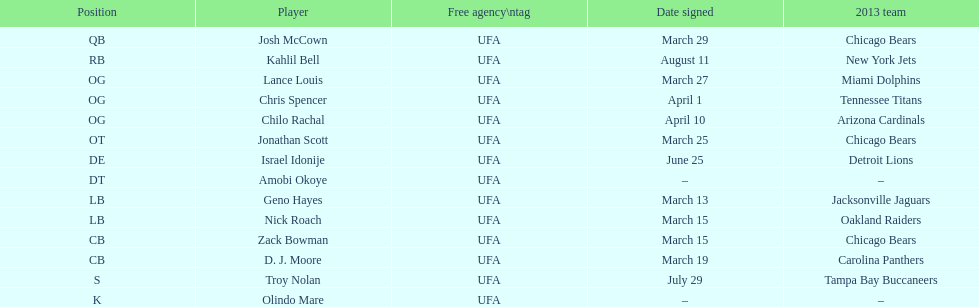Last name doubles as a forename beginning with "n" Troy Nolan. 